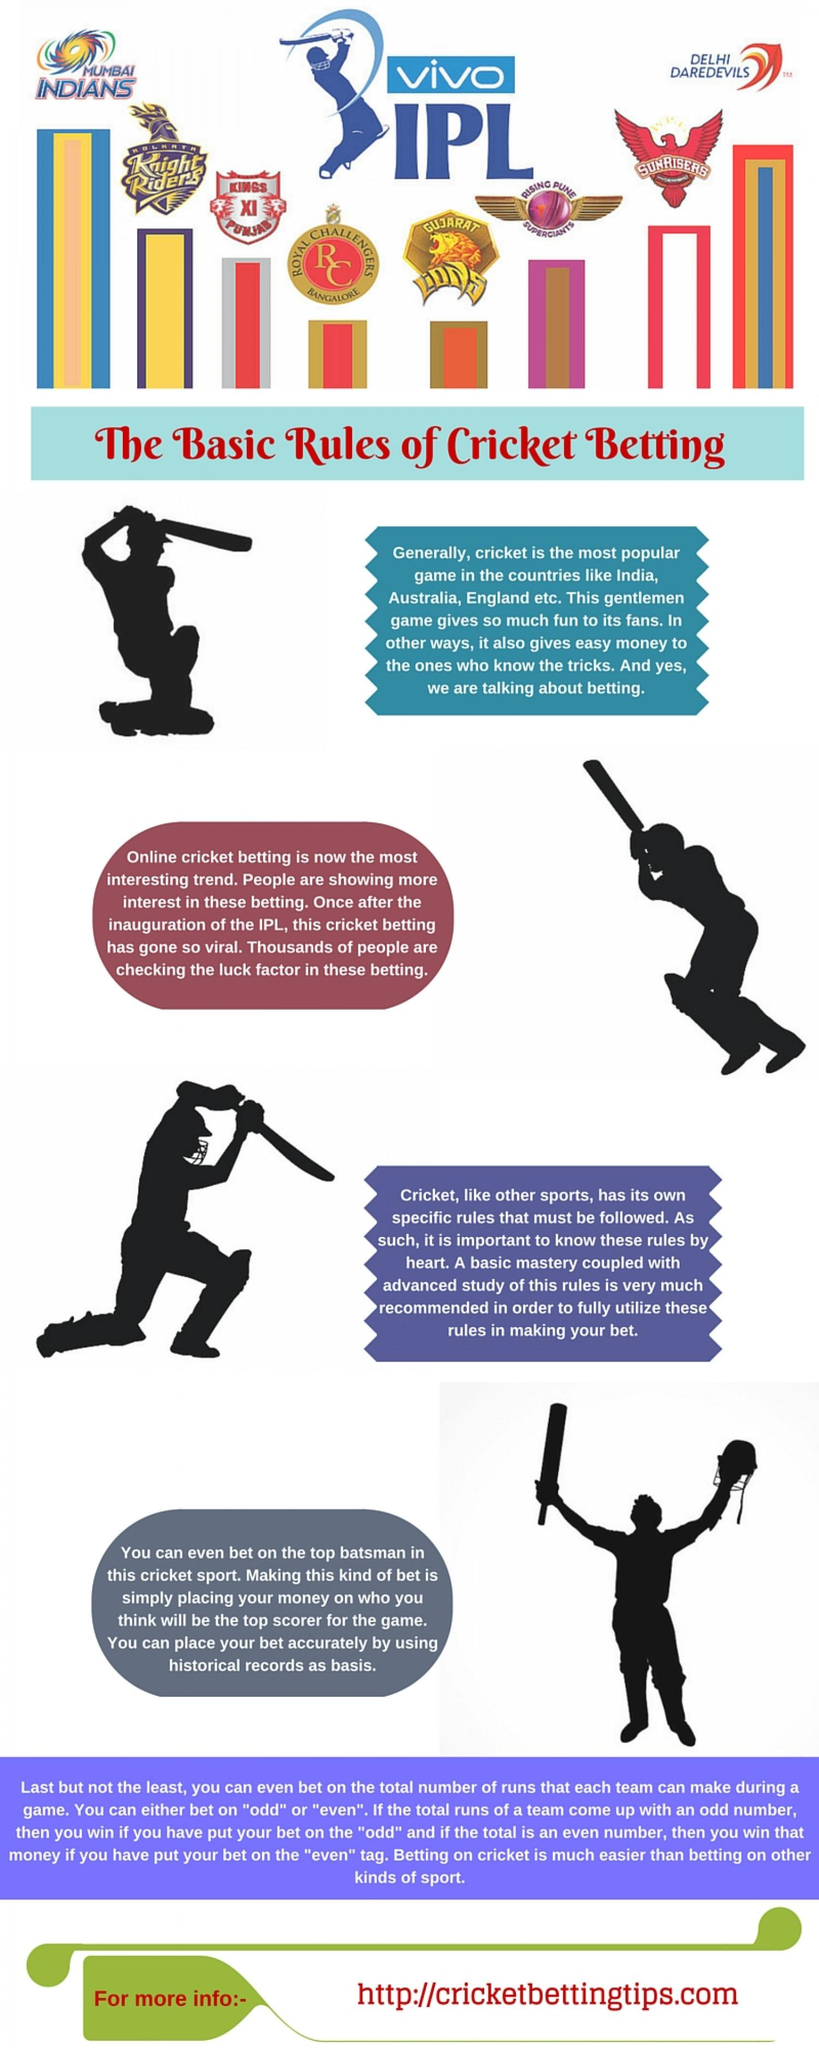Highlight a few significant elements in this photo. The infographic contains 8 IPL teams, as mentioned. The Knight Riders are the second IPL team mentioned in this infographic. 